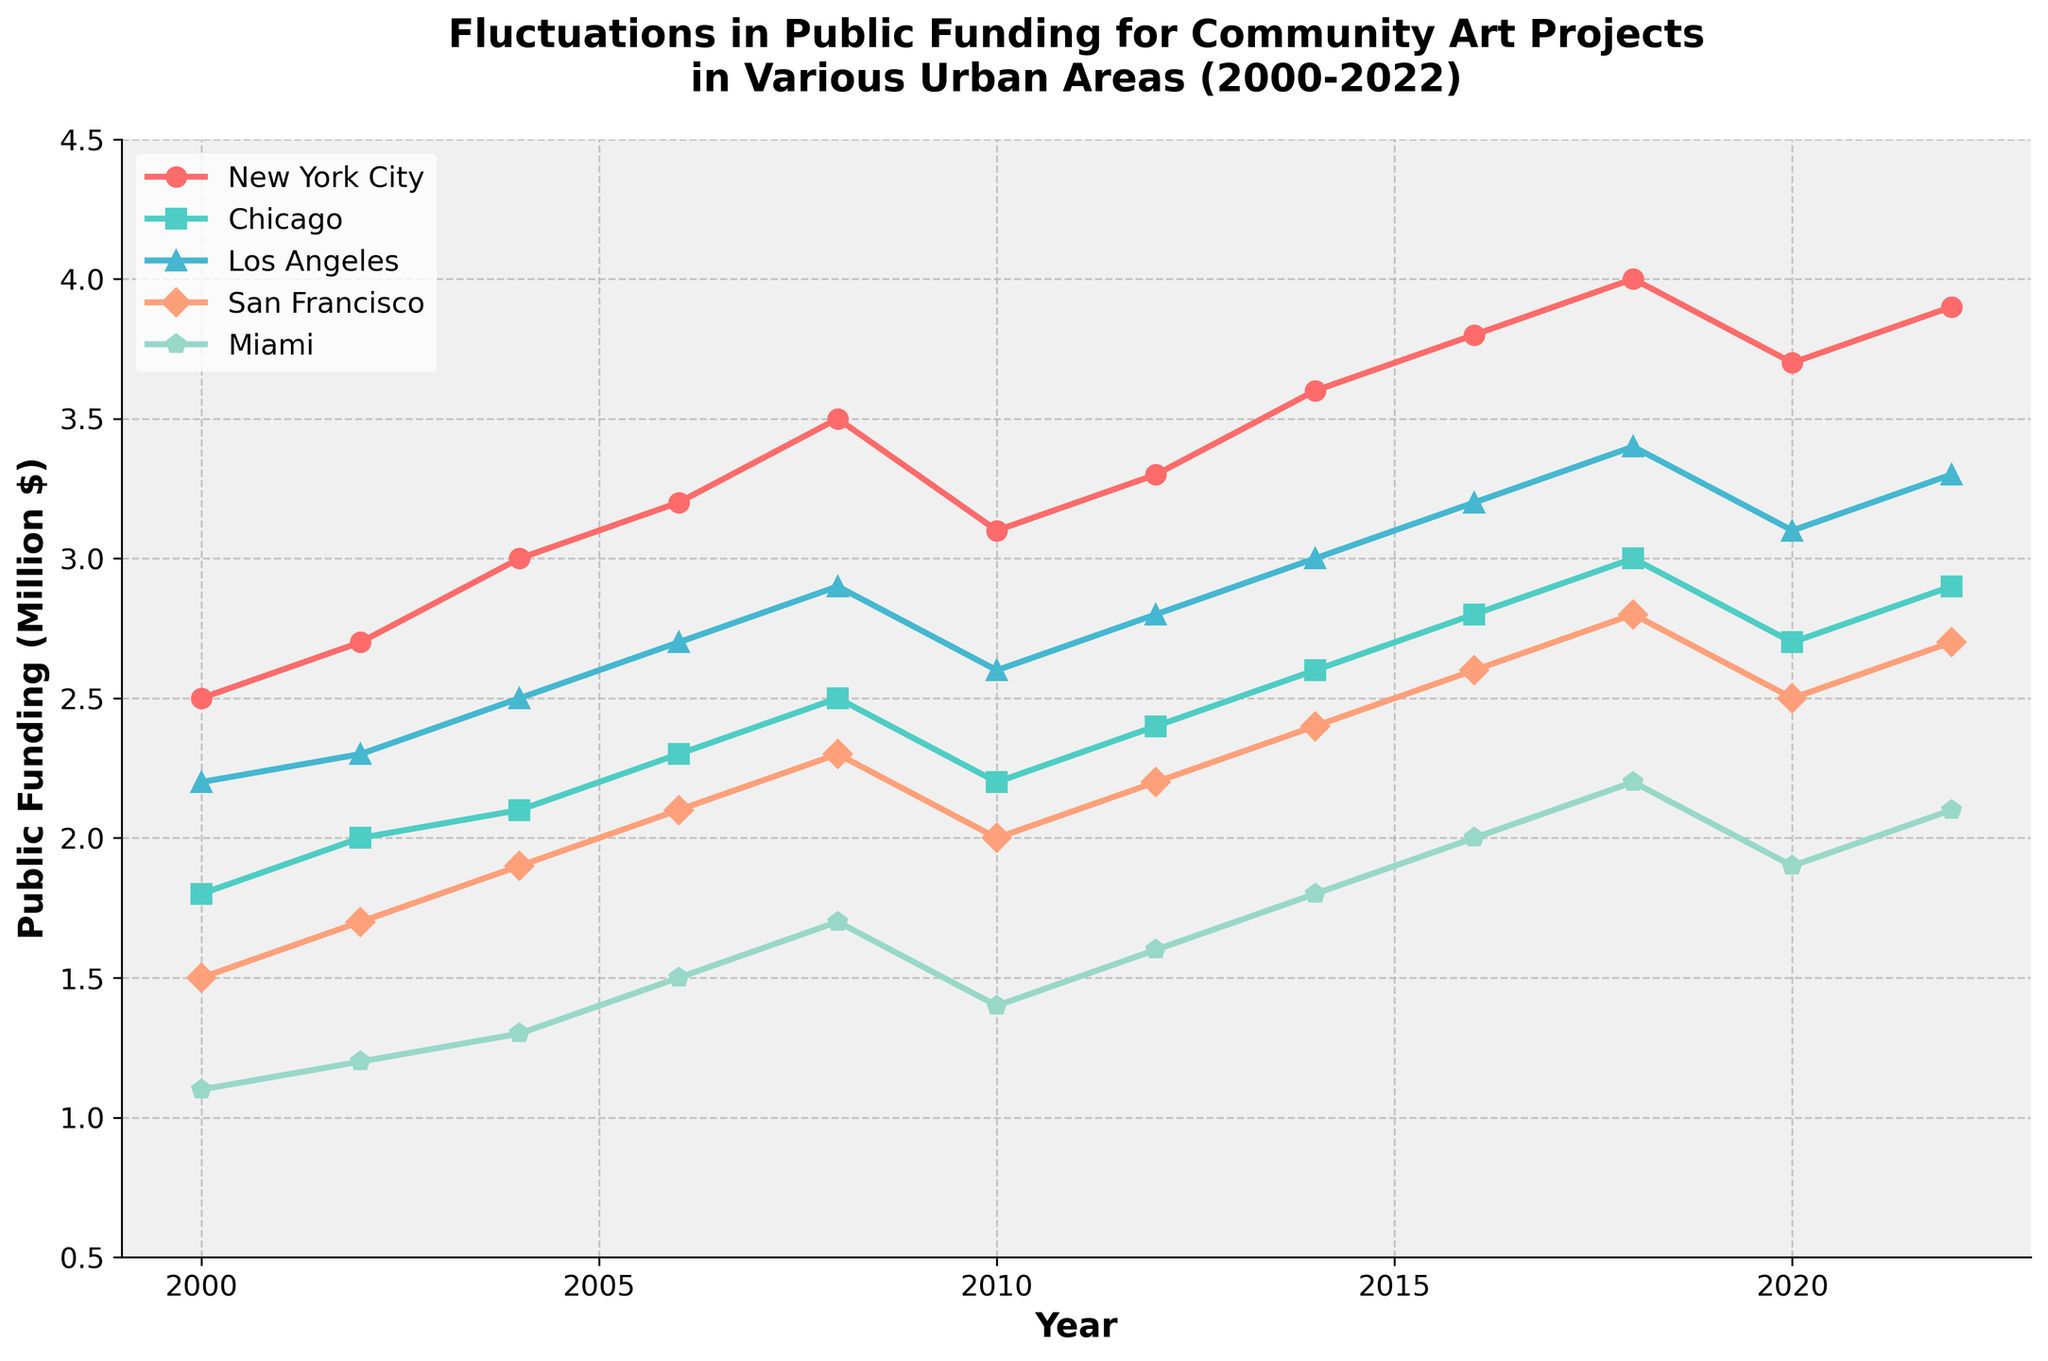What is the trend in public funding for community art projects in New York City from 2000 to 2022? New York City's funding shows an overall upward trend from 2.5 million dollars in 2000 to 3.9 million dollars in 2022, with slight fluctuations.
Answer: Upward trend Which city had the highest public funding for community art projects in 2018? In 2018, New York City had the highest public funding at 4 million dollars, as indicated by the highest point on the chart for that year.
Answer: New York City How did public funding in Miami change from 2004 to 2010? Miami's public funding increased from 1.3 million dollars in 2004 to 1.7 million dollars in 2008, then decreased to 1.4 million dollars in 2010.
Answer: Increased then decreased Which city had the least amount of public funding throughout the given period? Miami consistently had the lowest public funding across the years, with values starting at 1.1 million dollars in 2000 and reaching a maximum of 2.2 million dollars in 2018.
Answer: Miami What is the average public funding for Chicago from 2000 to 2022? To calculate the average, sum the annual values for Chicago and then divide by the number of years: (1.8 + 2.0 + 2.1 + 2.3 + 2.5 + 2.2 + 2.4 + 2.6 + 2.8 + 3.0 + 2.7 + 2.9) / 12. The total is 30.3, so the average is 30.3 / 12 = 2.525 million dollars.
Answer: 2.525 million dollars Between 2000 and 2022, which city showed the most significant increase in public funding? New York City showed the most significant increase, from 2.5 million dollars in 2000 to 3.9 million dollars in 2022, a change of 1.4 million dollars.
Answer: New York City What was the impact of the year 2010 on the funding trend in Los Angeles? In 2010, funding for Los Angeles dropped from 2.9 million dollars in 2008 to 2.6 million dollars, disrupting the previously upward trend.
Answer: Decreased How does the funding trend in San Francisco from 2000 to 2022 compare to that of Miami? San Francisco's funding trend shows a more consistent and higher increase compared to Miami. San Francisco's funding increased from 1.5 to 2.7 million dollars, while Miami's increased from 1.1 to 2.2 million dollars, with more fluctuations.
Answer: Higher and more consistent increase Visually, which city had the most stable funding without major fluctuations? Chicago's funding appears the most stable when looking at the chart, with relatively smooth and gradual increases, especially compared to other cities with more erratic changes.
Answer: Chicago Which years did New York City experience a decrease in public funding? New York City experienced decreases in funding from 2008 to 2010 (3.5 to 3.1 million dollars) and again from 2018 to 2020 (4.0 to 3.7 million dollars).
Answer: 2008-2010 and 2018-2020 